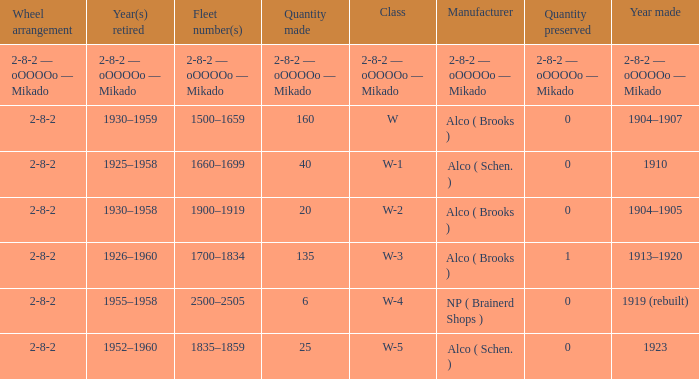What is the locomotive class that has a wheel arrangement of 2-8-2 and a quantity made of 25? W-5. 